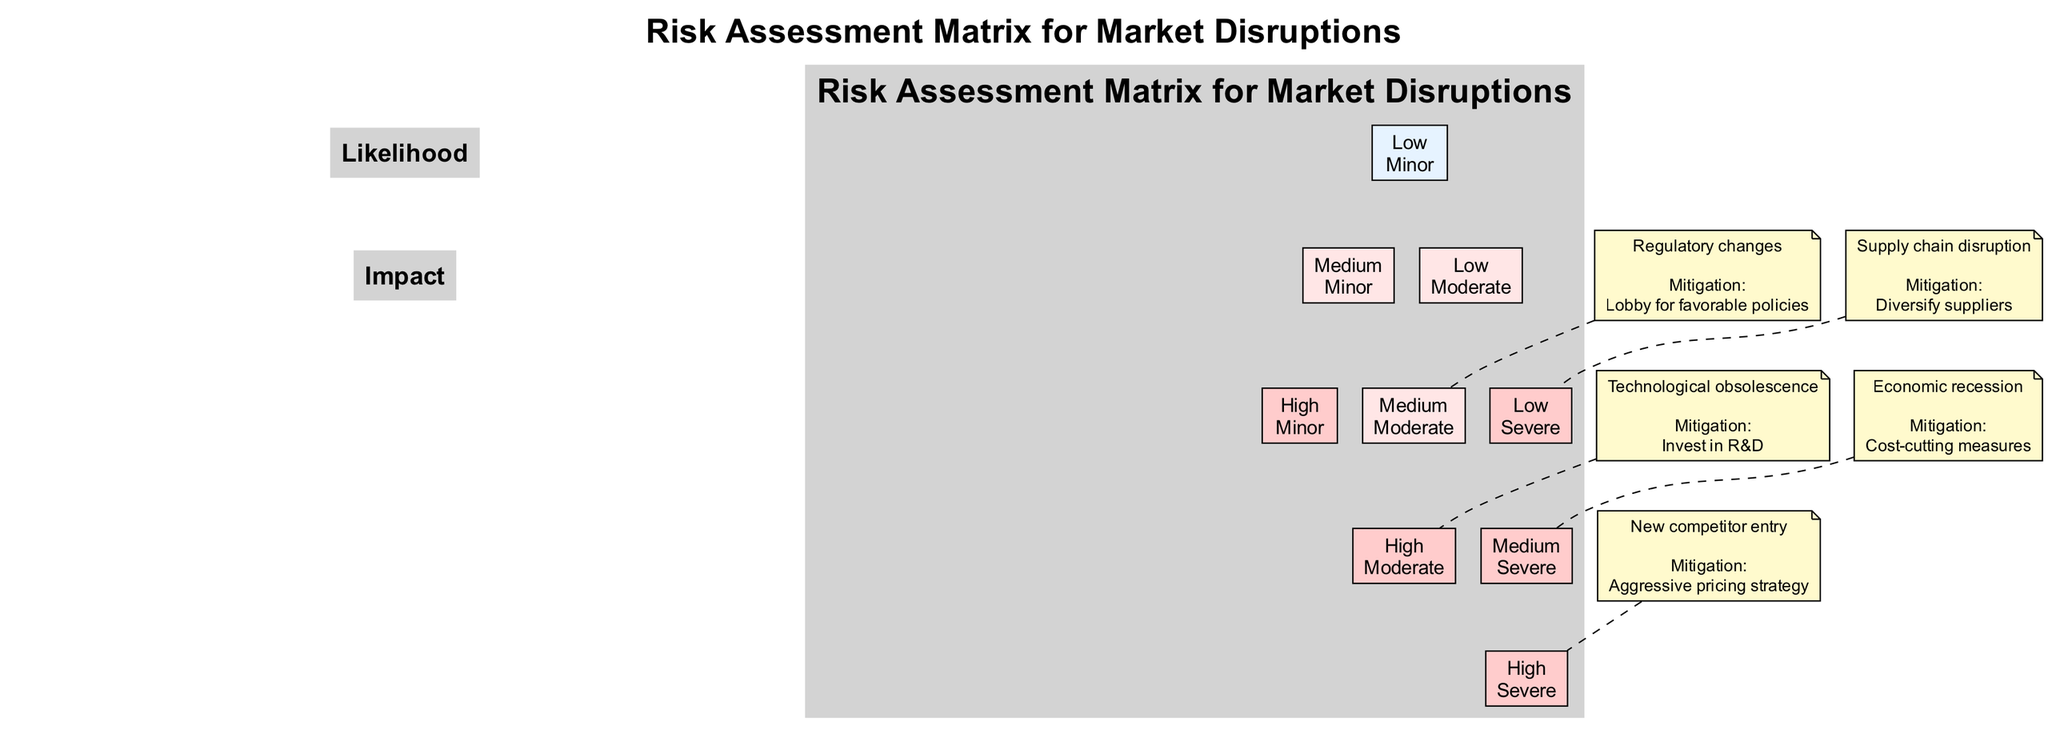What is the likelihood of a new competitor entry? The diagram indicates that the likelihood of a new competitor entry is categorized as "High." This can be seen in the risk assessment matrix where 'New competitor entry' is placed in the 'High' likelihood row.
Answer: High What is the mitigation strategy for supply chain disruption? In the risk assessment matrix, the mitigation strategy listed for supply chain disruption is to "Diversify suppliers." This information is included in the description under the corresponding risk node.
Answer: Diversify suppliers How many risks are categorized as having 'Severe' impact? Counting the risks in the diagram, we can see that there are three risks that have been categorized with a 'Severe' impact: 'New competitor entry,' 'Economic recession,' and 'Supply chain disruption.' Thus, the total is three.
Answer: 3 Which risk has a 'Moderate' impact and a 'High' likelihood? Referring to the diagram, the risk that fits the criteria of having both a 'Moderate' impact and a 'High' likelihood is identified as 'Technological obsolescence.' This can be found listed in the appropriate cell of the matrix.
Answer: Technological obsolescence What is the relationship between regulatory changes and the likelihood of its occurrence? In the diagram, regulatory changes are categorized under 'Medium' likelihood. This means that the occurrence of regulatory changes is assessed as being moderate in terms of probability, as indicated in the matrix where it resides.
Answer: Medium Which two risks share the same likelihood level? In the diagram, both 'Economic recession' and 'Regulatory changes' are categorized as having a 'Medium' likelihood. This shared classification can be seen by examining the likelihood row in the risk assessment matrix.
Answer: Economic recession, Regulatory changes How many total nodes are present in the risk assessment matrix? By analyzing the diagram, we can identify a total of six risk nodes (one for each risk) alongside additional nodes representing the levels of likelihood and impact. Hence, the total node count is seven.
Answer: 7 What is the name of the risk associated with the mitigation strategy "Aggressive pricing strategy"? According to the diagram, the risk that is associated with the mitigation strategy "Aggressive pricing strategy" is identified as 'New competitor entry.' This can be directly seen next to the risk in the matrix.
Answer: New competitor entry What is the impact of the supply chain disruption risk? The diagram clearly states that the impact of the supply chain disruption risk is categorized as 'Severe.' This is identifiable in the corresponding impact section of the matrix where it is positioned.
Answer: Severe 